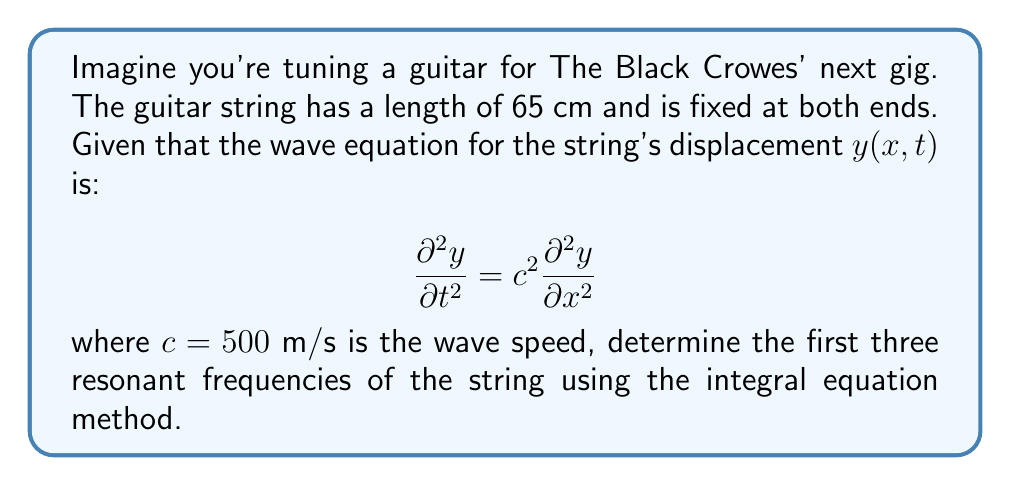Can you solve this math problem? To solve this problem, we'll follow these steps:

1) The general solution for the wave equation is:
   $$y(x,t) = [A \sin(kx) + B \cos(kx)][C \sin(\omega t) + D \cos(\omega t)]$$
   where $k$ is the wave number and $\omega$ is the angular frequency.

2) Given the fixed ends at $x=0$ and $x=L$ (where $L=0.65$ m), we have the boundary conditions:
   $$y(0,t) = 0 \text{ and } y(L,t) = 0$$

3) Applying these conditions, we get:
   $$B = 0 \text{ and } \sin(kL) = 0$$

4) The solution for $\sin(kL) = 0$ is:
   $$kL = n\pi, \text{ where } n = 1, 2, 3, ...$$

5) Substituting $k = n\pi/L$ into the dispersion relation $\omega = ck$:
   $$\omega_n = \frac{n\pi c}{L}$$

6) The frequency $f_n$ is related to $\omega_n$ by $\omega_n = 2\pi f_n$, so:
   $$f_n = \frac{nc}{2L}$$

7) Substituting the values $c = 500$ m/s and $L = 0.65$ m:
   $$f_n = \frac{n(500)}{2(0.65)} = 384.62n \text{ Hz}$$

8) For the first three resonant frequencies $(n = 1, 2, 3)$:
   $$f_1 = 384.62 \text{ Hz}$$
   $$f_2 = 769.24 \text{ Hz}$$
   $$f_3 = 1153.86 \text{ Hz}$$
Answer: $f_1 = 384.62$ Hz, $f_2 = 769.24$ Hz, $f_3 = 1153.86$ Hz 